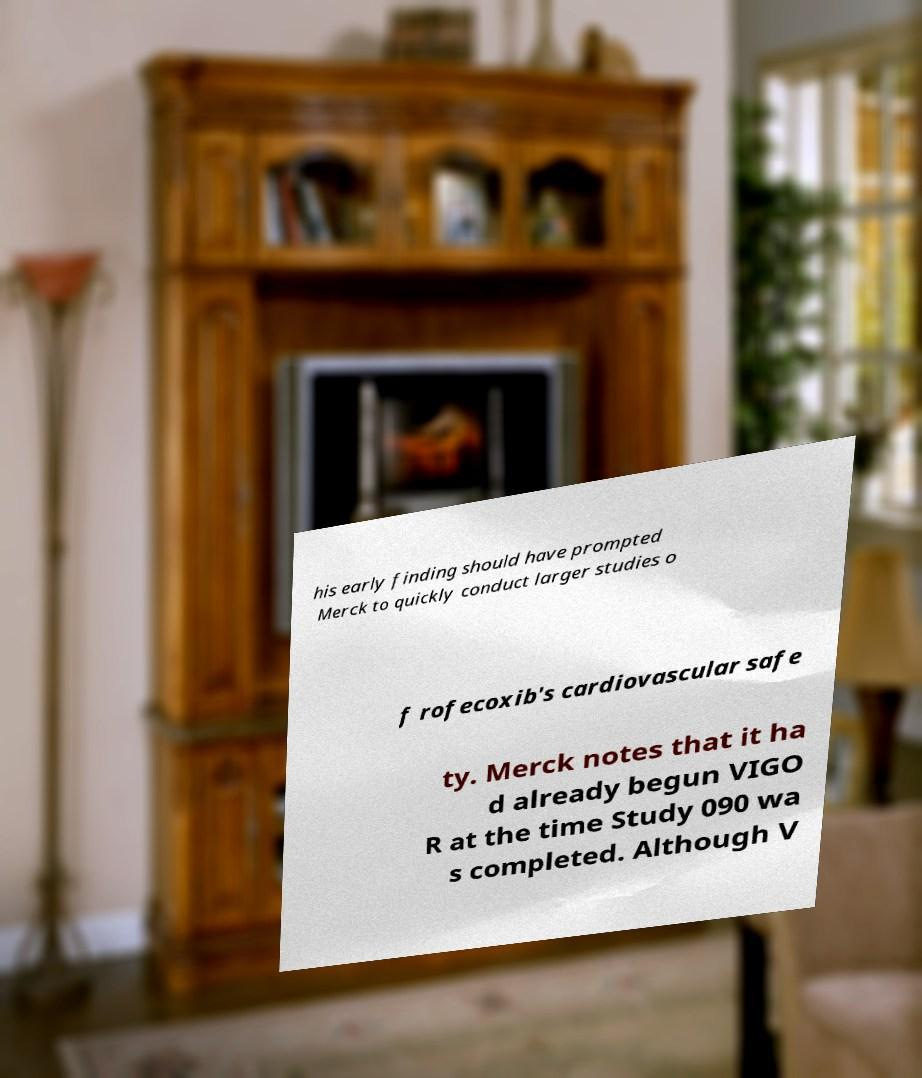Please read and relay the text visible in this image. What does it say? his early finding should have prompted Merck to quickly conduct larger studies o f rofecoxib's cardiovascular safe ty. Merck notes that it ha d already begun VIGO R at the time Study 090 wa s completed. Although V 